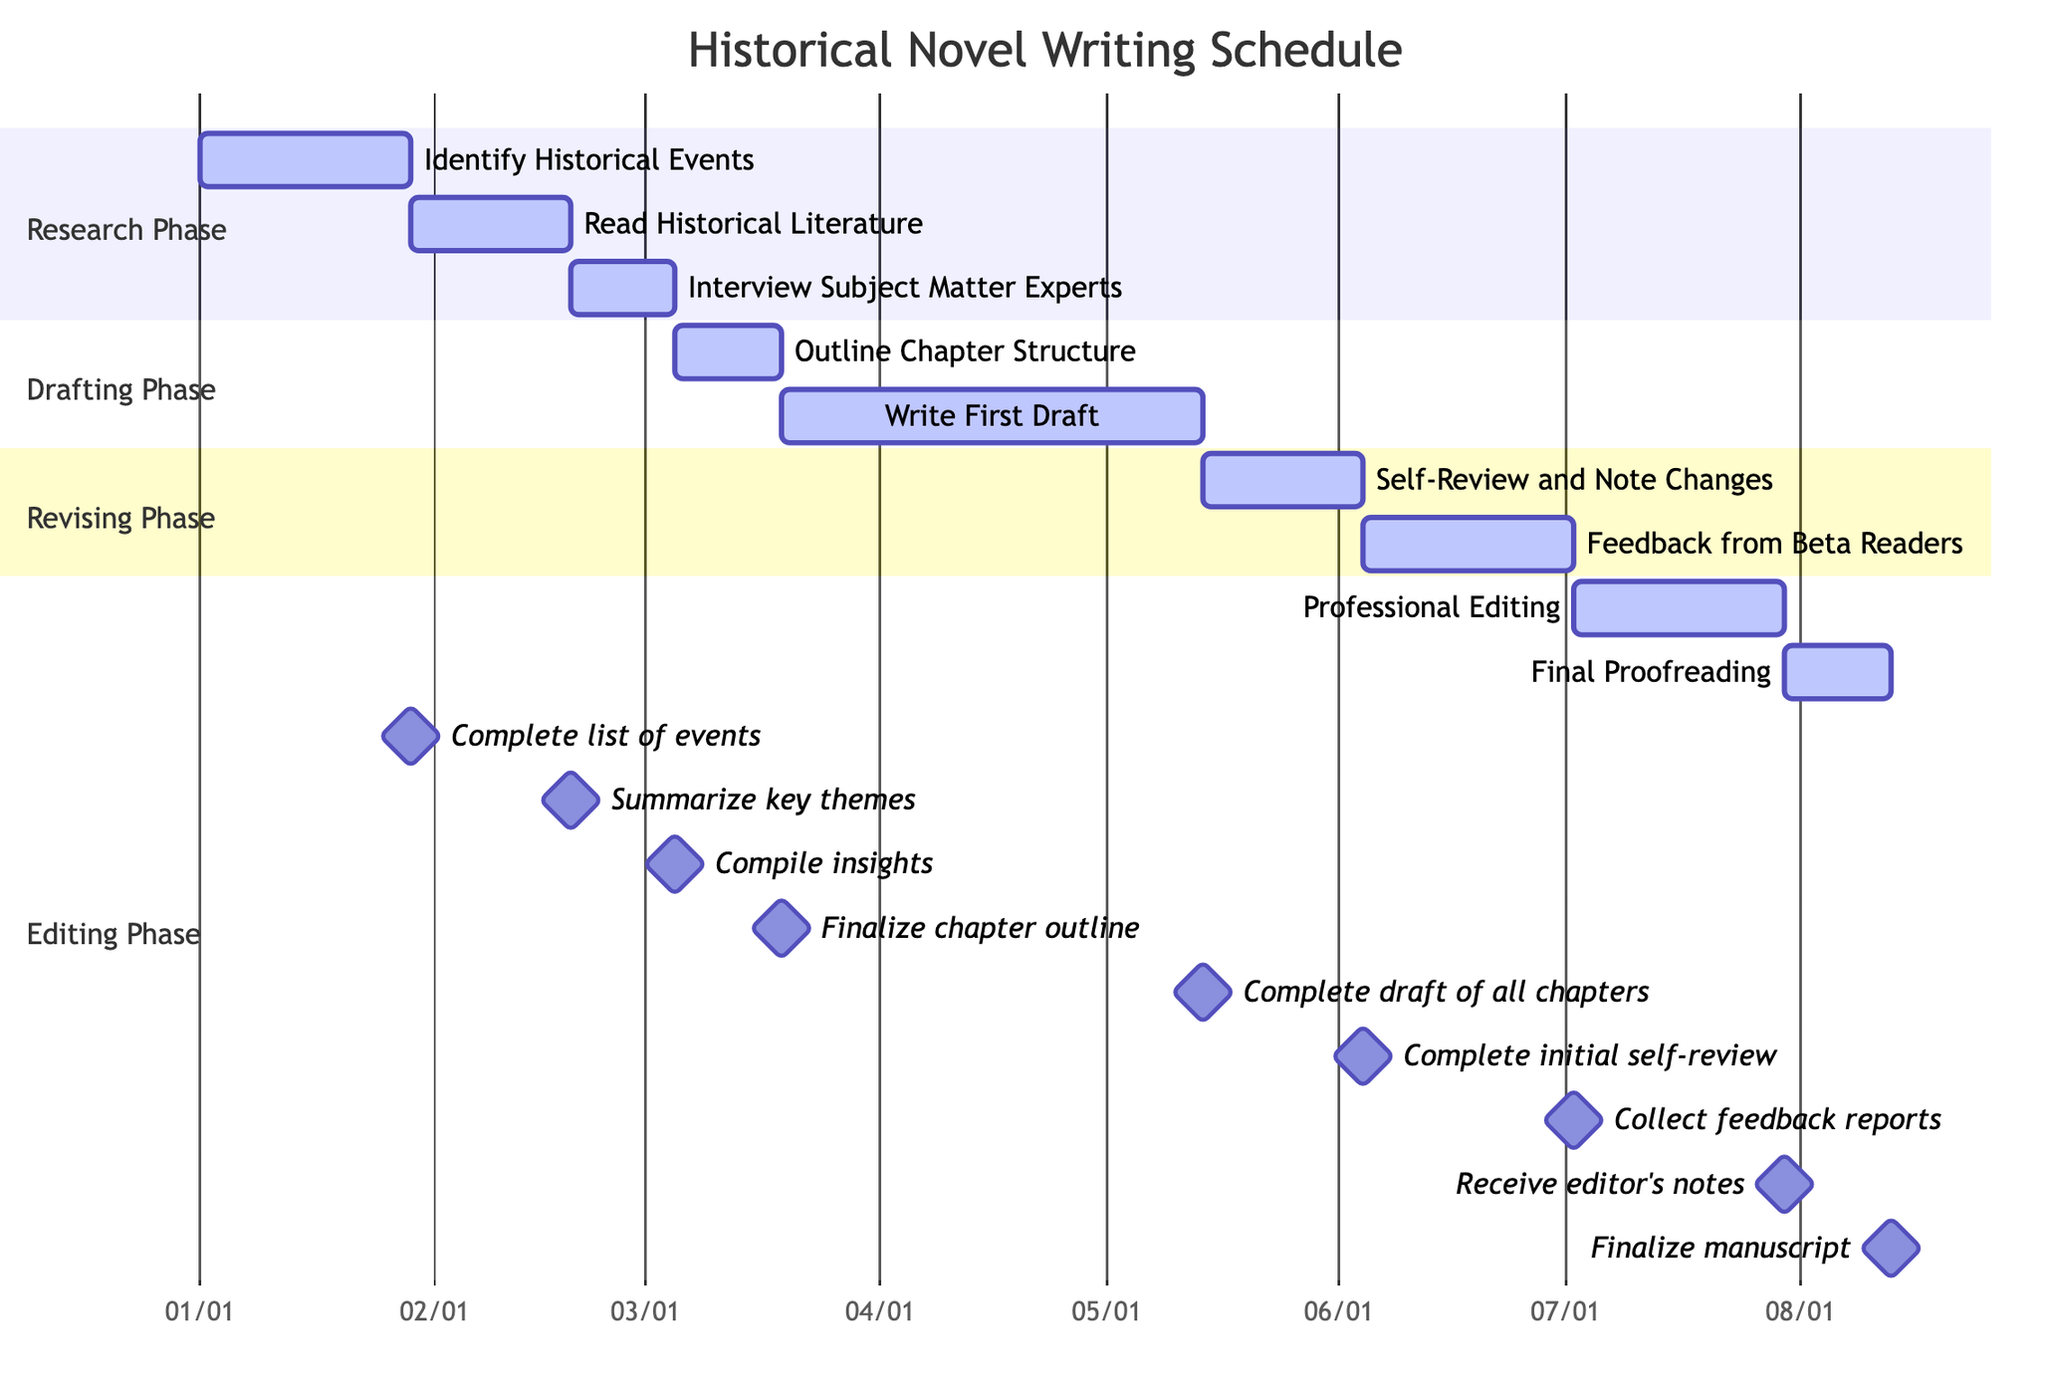What is the total duration of the Research Phase? The Research Phase consists of three tasks: "Identify Historical Events" (4 weeks), "Read Historical Literature" (3 weeks), and "Interview Subject Matter Experts" (2 weeks). Adding these durations together, 4 + 3 + 2 equals 9 weeks.
Answer: 9 weeks How many tasks are there in the Drafting Phase? The Drafting Phase has two tasks: "Outline Chapter Structure" and "Write First Draft." Therefore, there are a total of 2 tasks in this phase.
Answer: 2 tasks What milestone corresponds to the completion of the First Draft? The task "Write First Draft" has "Complete draft of all chapters" marked as its milestone. Therefore, this milestone corresponds to the completion of the First Draft.
Answer: Complete draft of all chapters Which phase comes immediately after the Drafting Phase? The Drafting Phase is followed by the Revising Phase. To identify this, we look at the sequence of phases and locate the one after Drafting.
Answer: Revising Phase What is the duration of the Feedback from Beta Readers task? The task "Feedback from Beta Readers" is scheduled for a duration of 4 weeks. This information is directly provided in the task details under the Revising Phase.
Answer: 4 weeks Which task has the longest duration in the entire schedule? The task "Write First Draft" has a duration of 8 weeks, which is the longest duration when compared to all other tasks in the chart. Therefore, it stands out as the task with the longest timeframe.
Answer: Write First Draft How many milestones are associated with the Editing Phase? The Editing Phase comprises two tasks: "Professional Editing" and "Final Proofreading." There are milestones for each task - "Receive editor's notes" and "Finalize manuscript." Thus, there are 2 milestones associated with the Editing Phase.
Answer: 2 milestones What is the starting date of the Self-Review and Note Changes task? The task "Self-Review and Note Changes" starts on May 14, 2023, as indicated in the Gantt Chart's timeline for the Revising Phase.
Answer: May 14, 2023 Which task concludes just before the Final Proofreading task? The "Professional Editing" task concludes just before the "Final Proofreading" task, as evidenced by the sequential order of tasks in the Editing Phase.
Answer: Professional Editing 